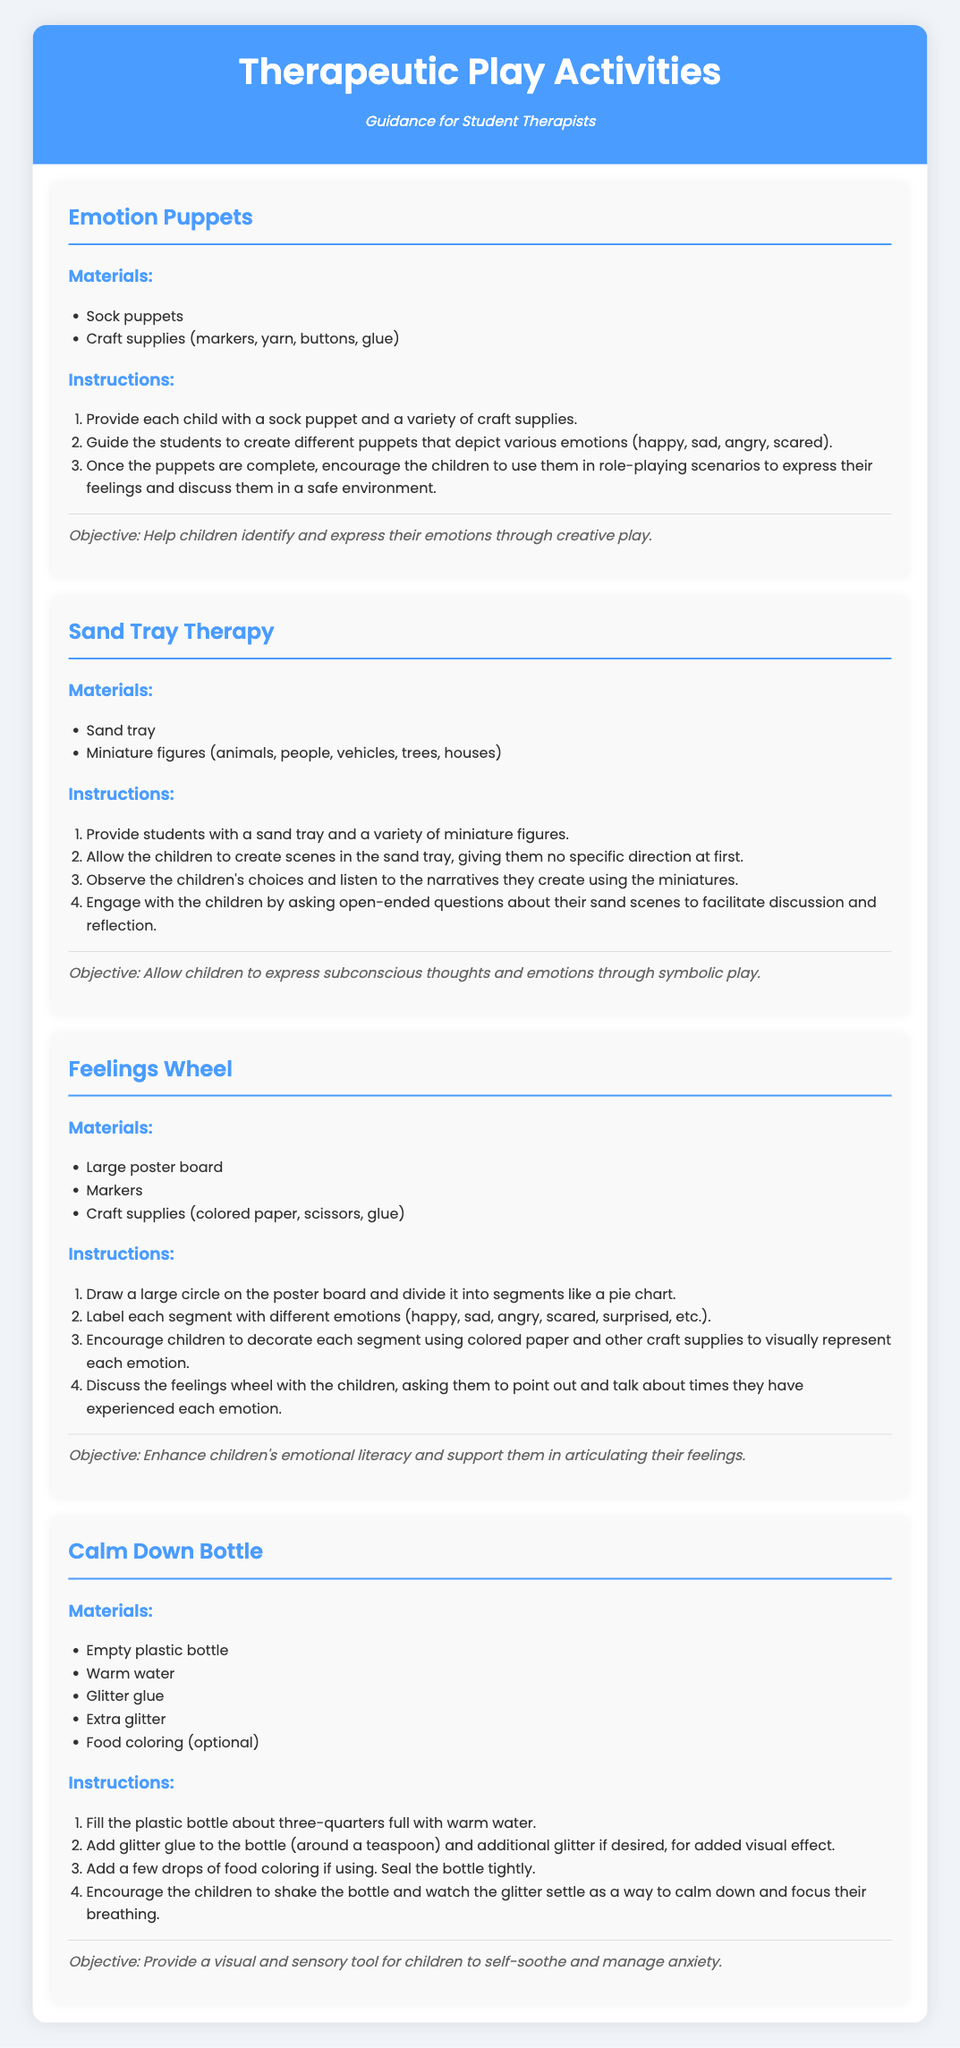What is the title of the document? The title of the document is stated at the top of the recipe card.
Answer: Therapeutic Play Activities How many emotions can be represented with the Emotion Puppets? The Emotion Puppets activity specifies the emotions children should create puppets for.
Answer: Four What materials are needed for the Sand Tray Therapy? The materials are listed under the Sand Tray Therapy section of the document.
Answer: Sand tray, Miniature figures What is the main objective of the Feelings Wheel activity? The objective is mentioned in the description of the Feelings Wheel activity.
Answer: Enhance children's emotional literacy What kind of bottle is used in the Calm Down Bottle activity? The type of bottle is mentioned in the materials for the Calm Down Bottle.
Answer: Empty plastic bottle How many steps are listed in the instructions for making the Calm Down Bottle? The number of steps can be found in the instructions for that activity.
Answer: Four What craft supplies are suggested for creating Emotion Puppets? The craft supplies are mentioned under the materials for Emotion Puppets.
Answer: Markers, yarn, buttons, glue Which activity involves watching glitter settle? The activity that describes watching glitter settle is specified in its title and instructions.
Answer: Calm Down Bottle What is the main activity focus of the Sand Tray Therapy? The focus is highlighted in the objective of the Sand Tray Therapy activity.
Answer: Express subconscious thoughts and emotions 